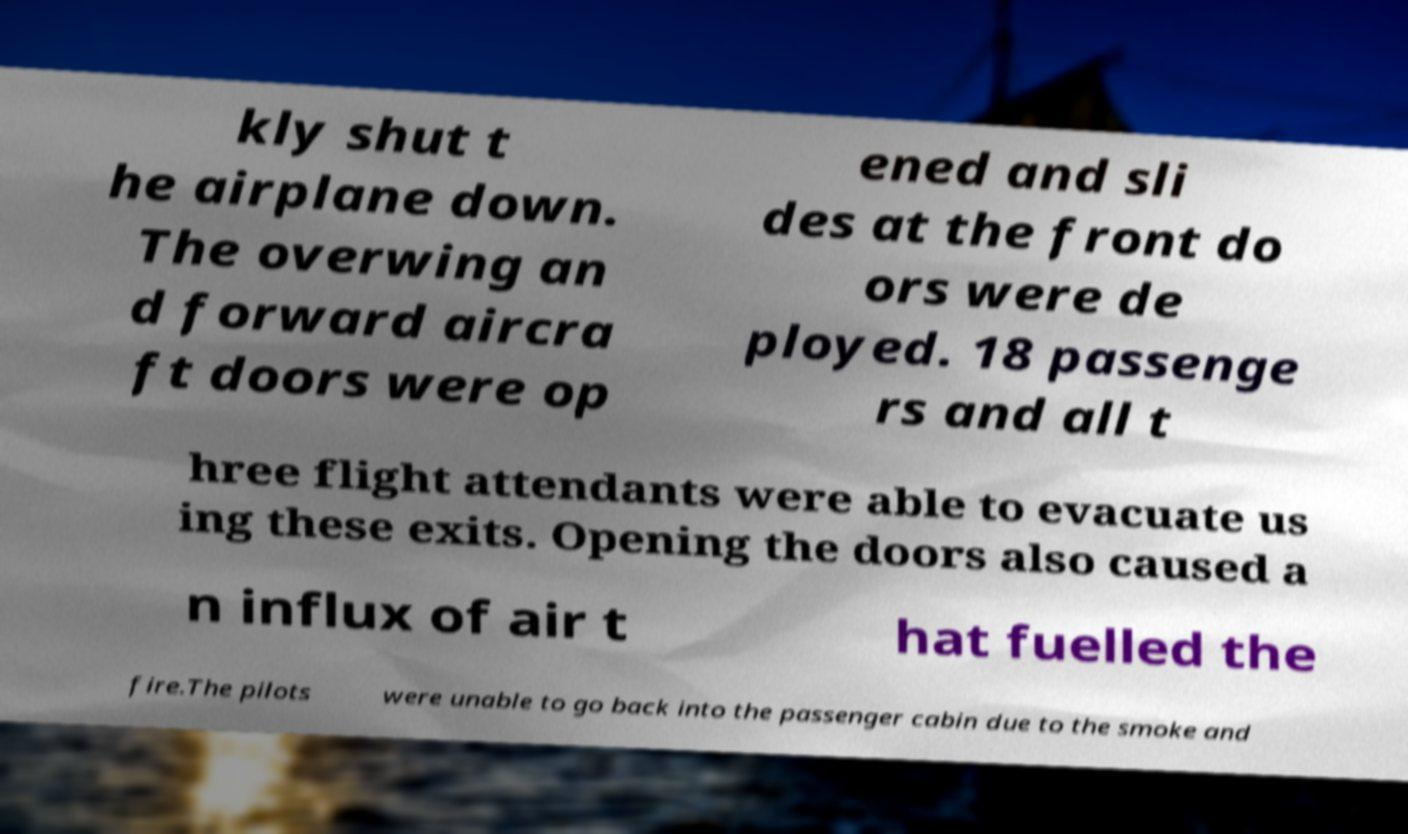Can you accurately transcribe the text from the provided image for me? kly shut t he airplane down. The overwing an d forward aircra ft doors were op ened and sli des at the front do ors were de ployed. 18 passenge rs and all t hree flight attendants were able to evacuate us ing these exits. Opening the doors also caused a n influx of air t hat fuelled the fire.The pilots were unable to go back into the passenger cabin due to the smoke and 